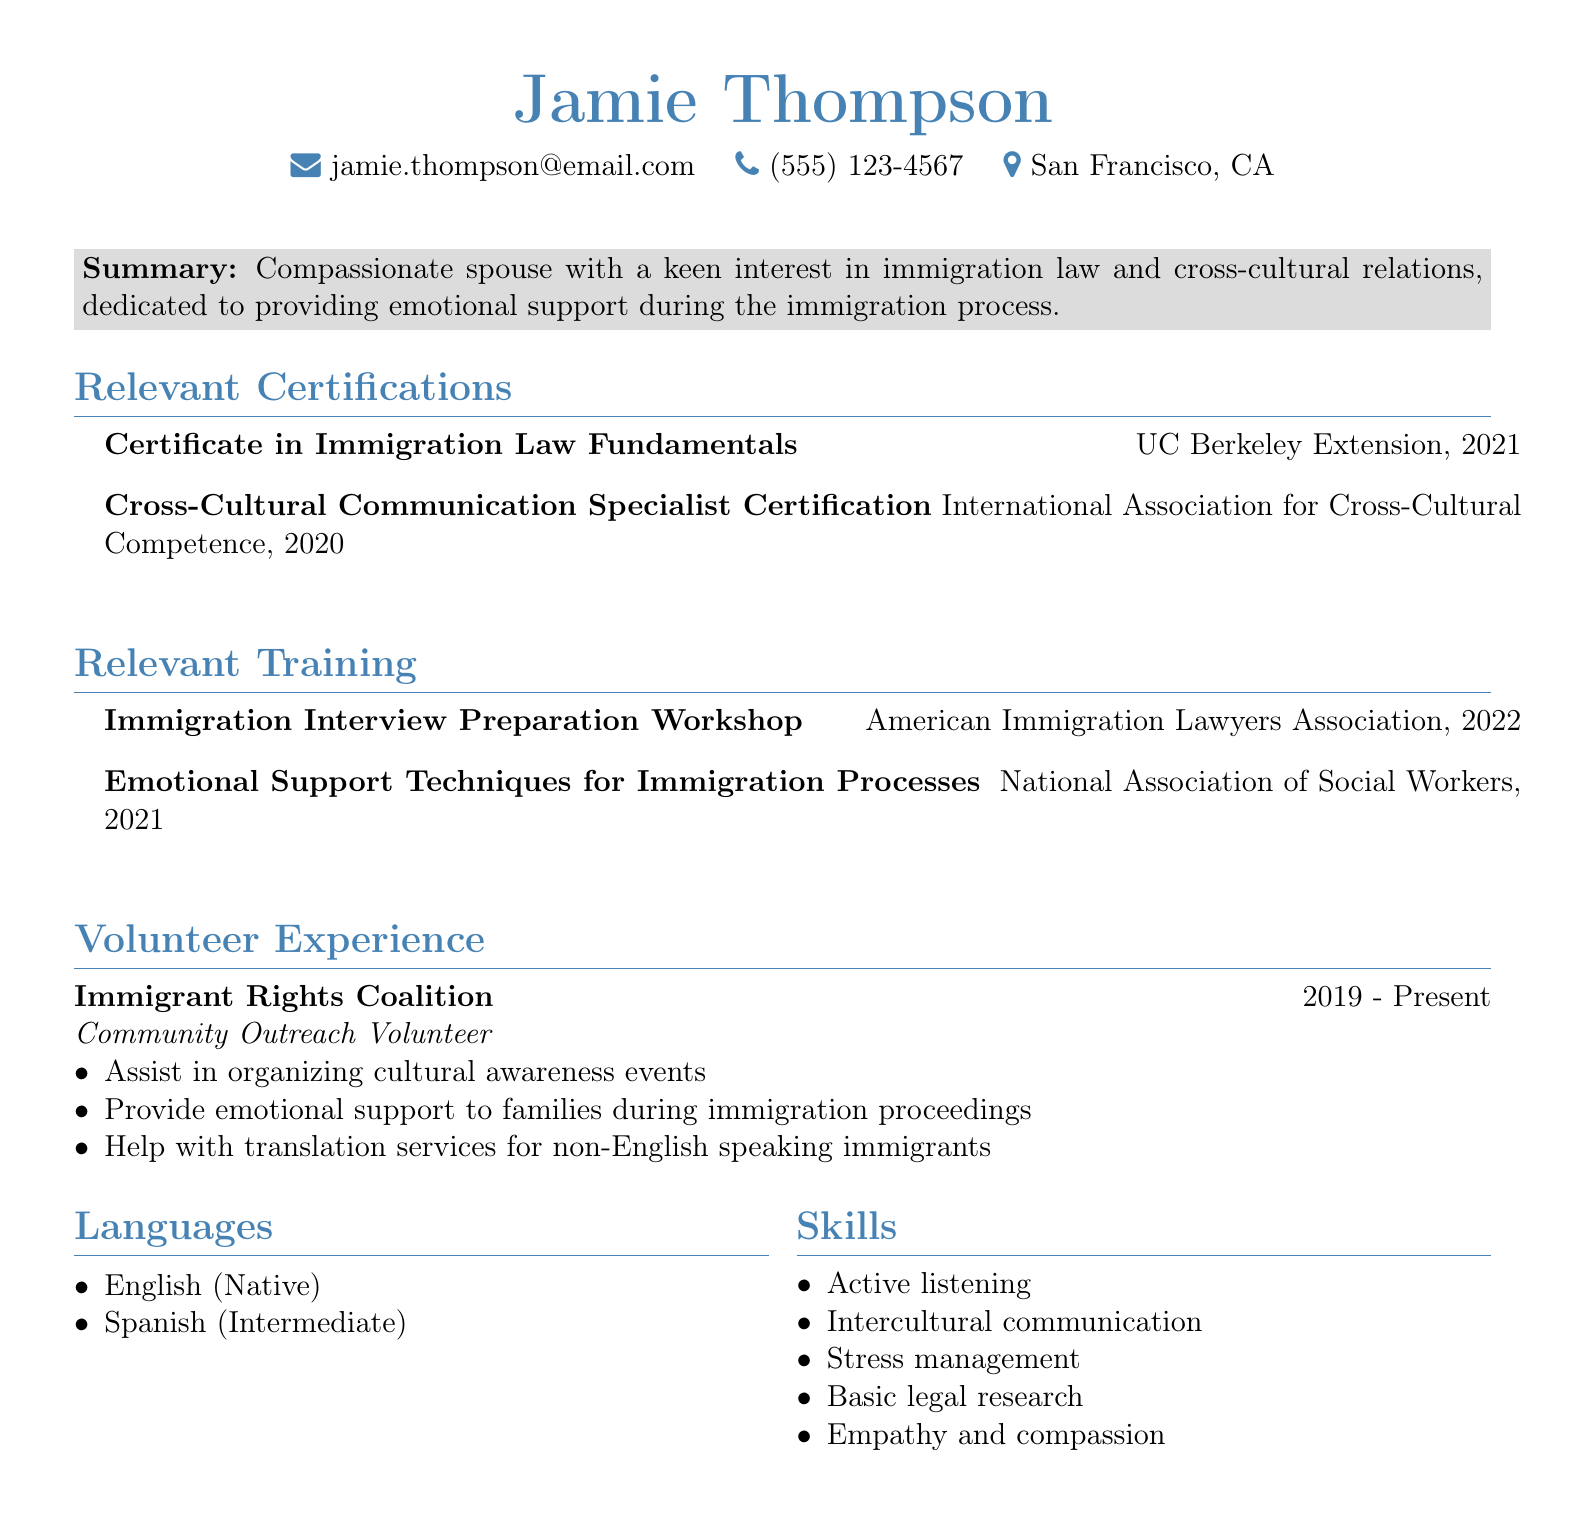What is Jamie Thompson's email address? The email address can be found in the personal information section of the resume.
Answer: jamie.thompson@email.com What year did Jamie obtain the Cross-Cultural Communication Specialist Certification? The year of certification is specified in the relevant certifications section of the resume.
Answer: 2020 Which organization provided the training for Immigration Interview Preparation? The provider of the training can be found in the relevant training section.
Answer: American Immigration Lawyers Association In what role does Jamie currently volunteer? The role of Jamie in the volunteer experience section indicates their position.
Answer: Community Outreach Volunteer How many skills are listed in the skills section? The skills section contains a list of specific skills Jamie possesses, and counting them gives the total.
Answer: 5 Why is Jamie Thompson's experience relevant to immigration support? By examining the summary and volunteer experience, we can see Jamie's focus and activities related to emotional support during immigration.
Answer: Emotional support What language proficiency does Jamie have besides English? The languages section indicates the other language Jamie can speak and its level of proficiency.
Answer: Spanish (Intermediate) What is the total duration of Jamie's volunteer experience? The volunteer experience section specifies the starting year and mentions that the position is ongoing, which needs to be interpreted to determine the duration.
Answer: 2019 - Present 